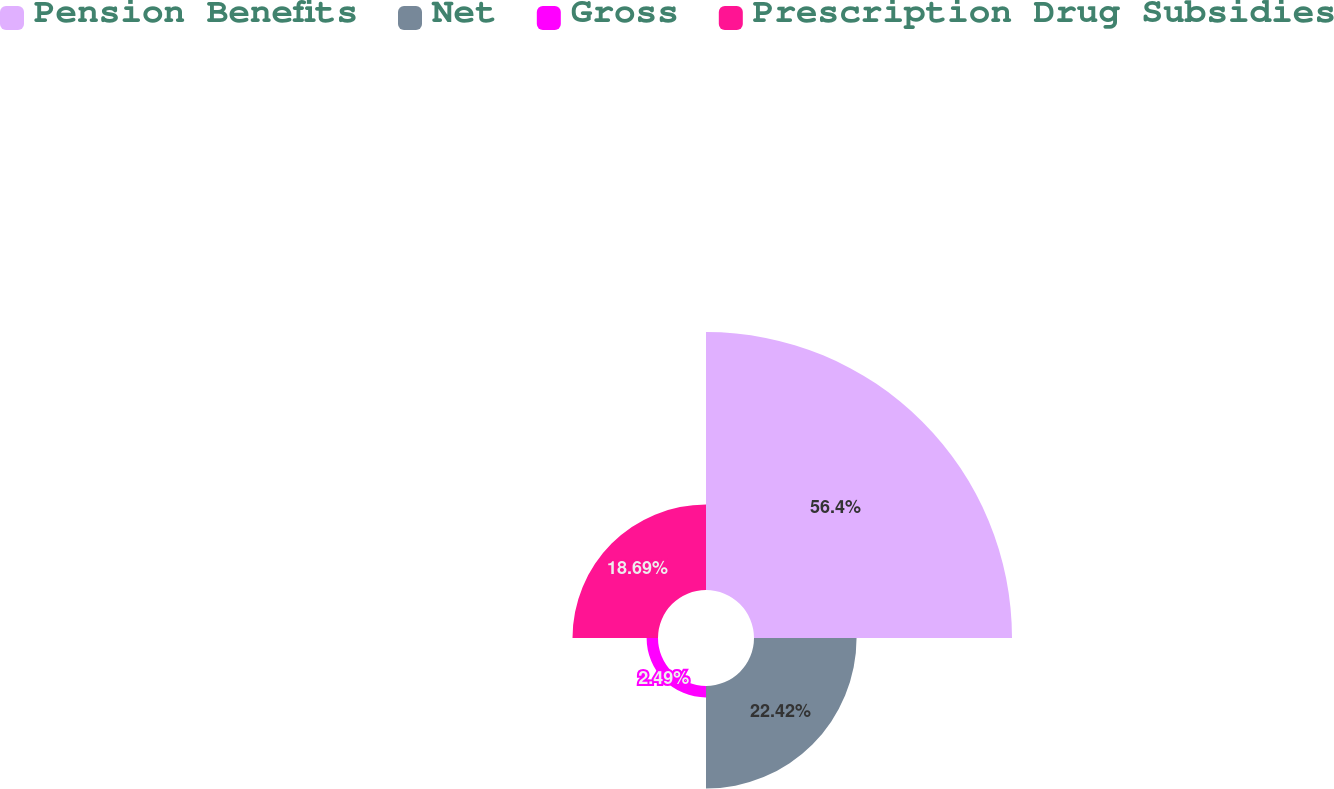Convert chart to OTSL. <chart><loc_0><loc_0><loc_500><loc_500><pie_chart><fcel>Pension Benefits<fcel>Net<fcel>Gross<fcel>Prescription Drug Subsidies<nl><fcel>56.4%<fcel>22.42%<fcel>2.49%<fcel>18.69%<nl></chart> 